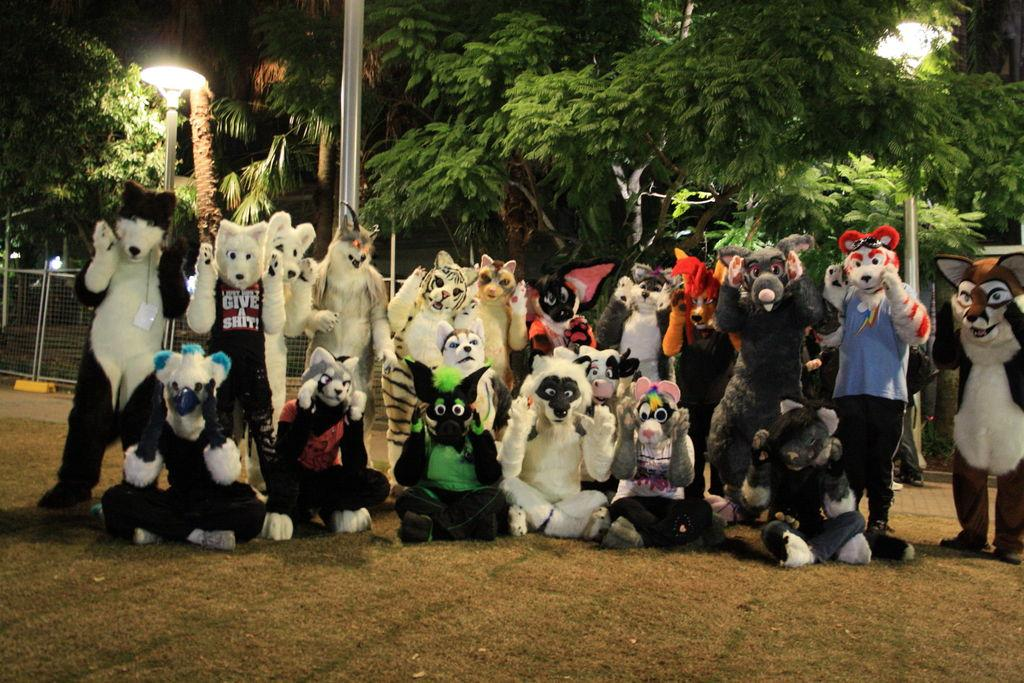How many people are in the image? There is a group of people in the image. What are the people wearing? The people are wearing costumes. What positions are the people in? Some people are standing, while others are sitting on the ground. What can be seen in the background of the image? There are poles, lights, trees, and a fence in the background of the image. What type of agreement is being discussed by the family in the image? There is no family present in the image, and no discussion or agreement can be observed. 